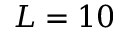<formula> <loc_0><loc_0><loc_500><loc_500>L = 1 0</formula> 